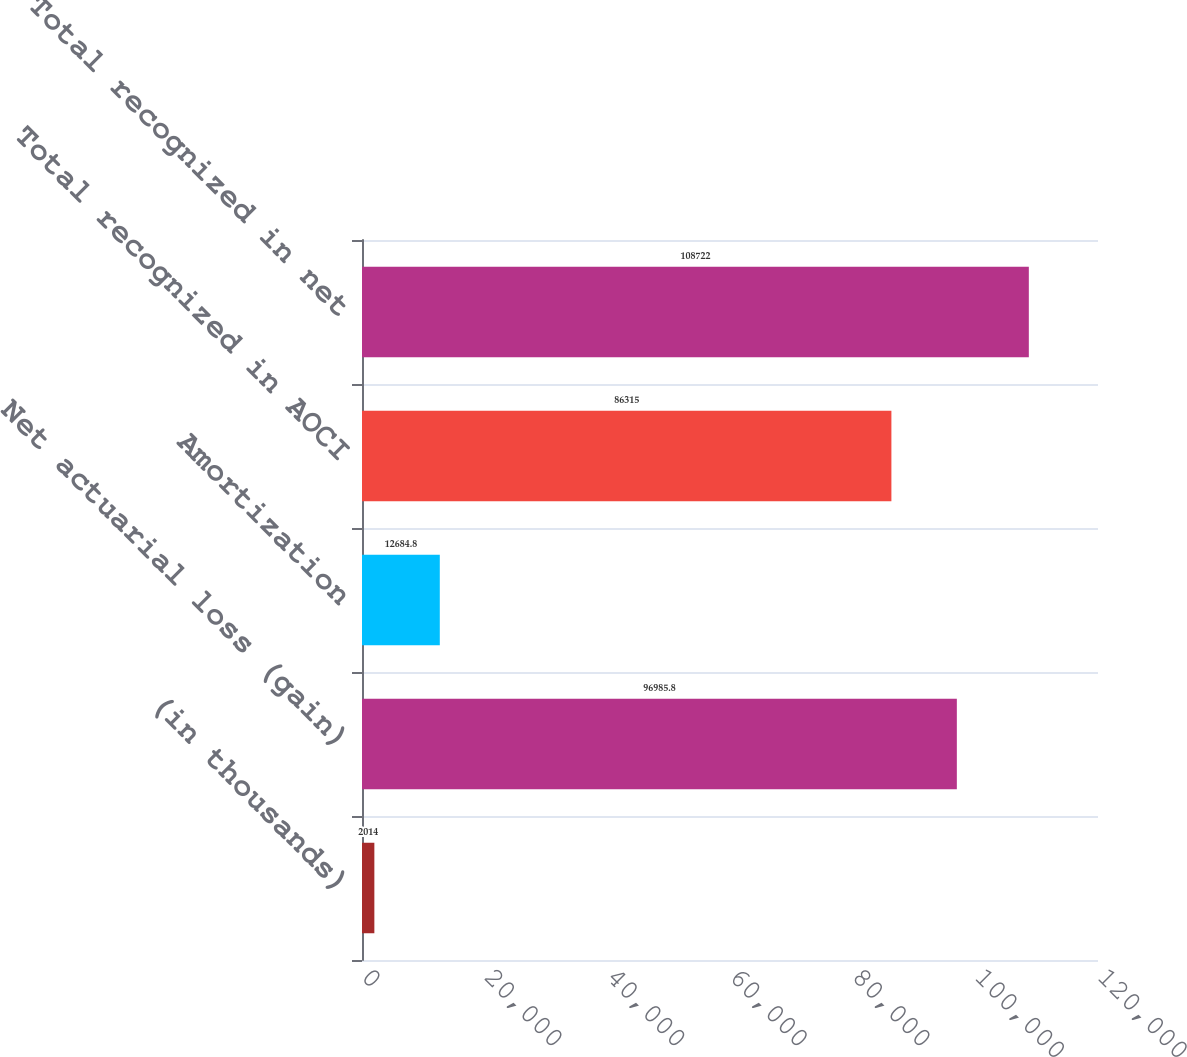Convert chart to OTSL. <chart><loc_0><loc_0><loc_500><loc_500><bar_chart><fcel>(in thousands)<fcel>Net actuarial loss (gain)<fcel>Amortization<fcel>Total recognized in AOCI<fcel>Total recognized in net<nl><fcel>2014<fcel>96985.8<fcel>12684.8<fcel>86315<fcel>108722<nl></chart> 